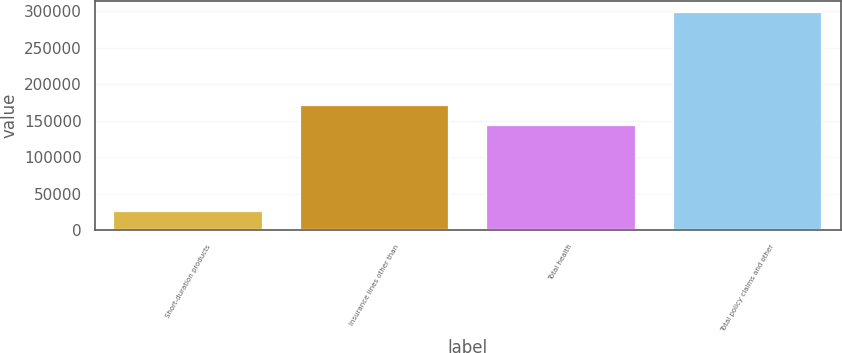<chart> <loc_0><loc_0><loc_500><loc_500><bar_chart><fcel>Short-duration products<fcel>Insurance lines other than<fcel>Total health<fcel>Total policy claims and other<nl><fcel>26721<fcel>170976<fcel>143691<fcel>299565<nl></chart> 